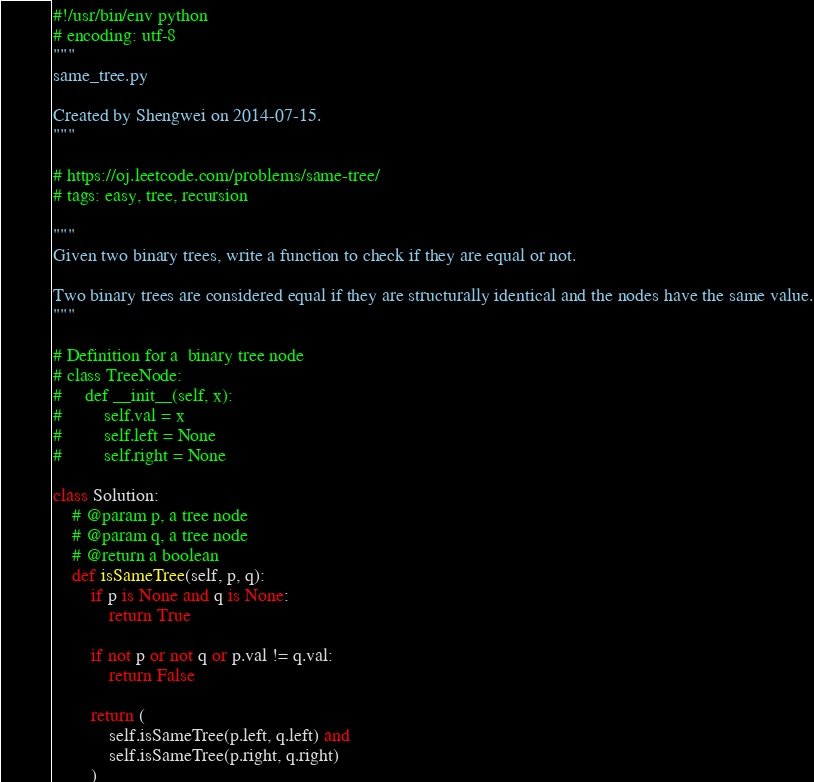<code> <loc_0><loc_0><loc_500><loc_500><_Python_>#!/usr/bin/env python
# encoding: utf-8
"""
same_tree.py

Created by Shengwei on 2014-07-15.
"""

# https://oj.leetcode.com/problems/same-tree/
# tags: easy, tree, recursion

"""
Given two binary trees, write a function to check if they are equal or not.

Two binary trees are considered equal if they are structurally identical and the nodes have the same value.
"""

# Definition for a  binary tree node
# class TreeNode:
#     def __init__(self, x):
#         self.val = x
#         self.left = None
#         self.right = None

class Solution:
    # @param p, a tree node
    # @param q, a tree node
    # @return a boolean
    def isSameTree(self, p, q):
        if p is None and q is None:
            return True
        
        if not p or not q or p.val != q.val:
            return False
        
        return (
            self.isSameTree(p.left, q.left) and
            self.isSameTree(p.right, q.right)
        )
</code> 